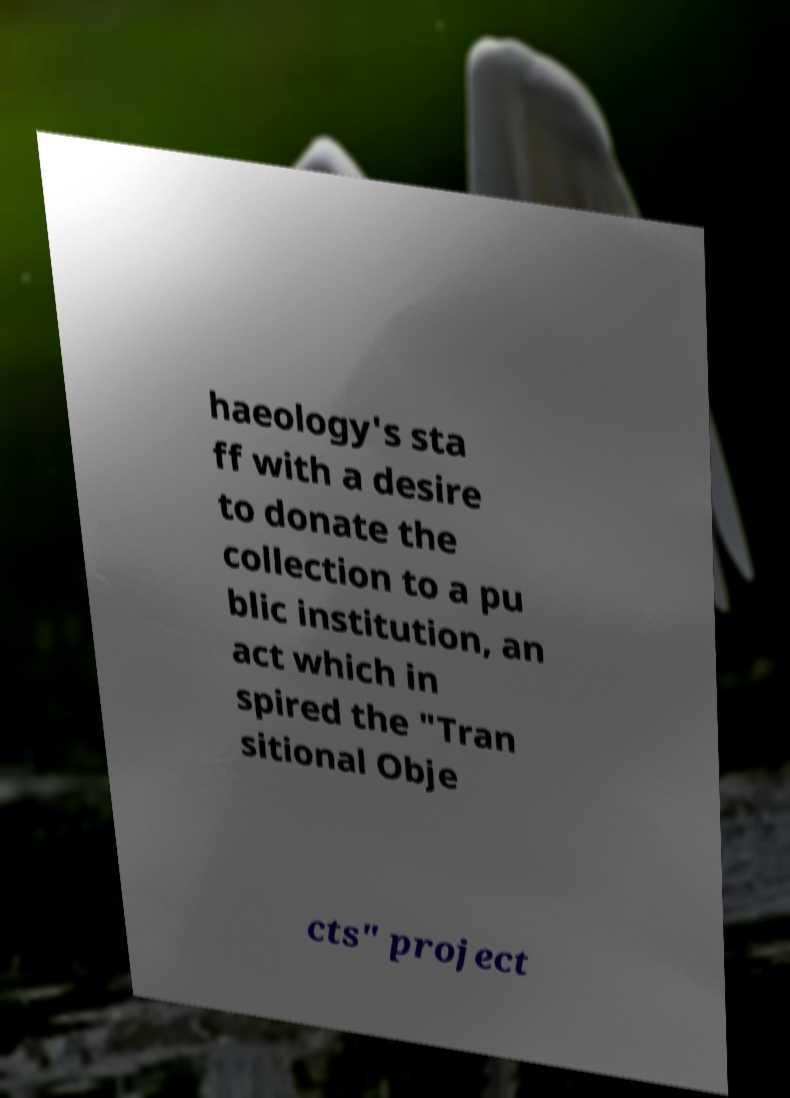Can you read and provide the text displayed in the image?This photo seems to have some interesting text. Can you extract and type it out for me? haeology's sta ff with a desire to donate the collection to a pu blic institution, an act which in spired the "Tran sitional Obje cts" project 